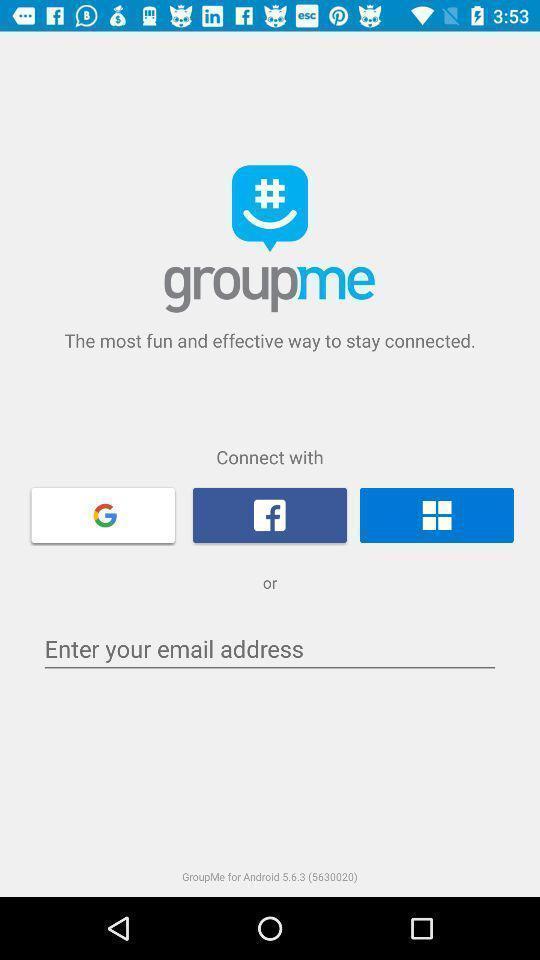Provide a textual representation of this image. Welcome page of a social application. 